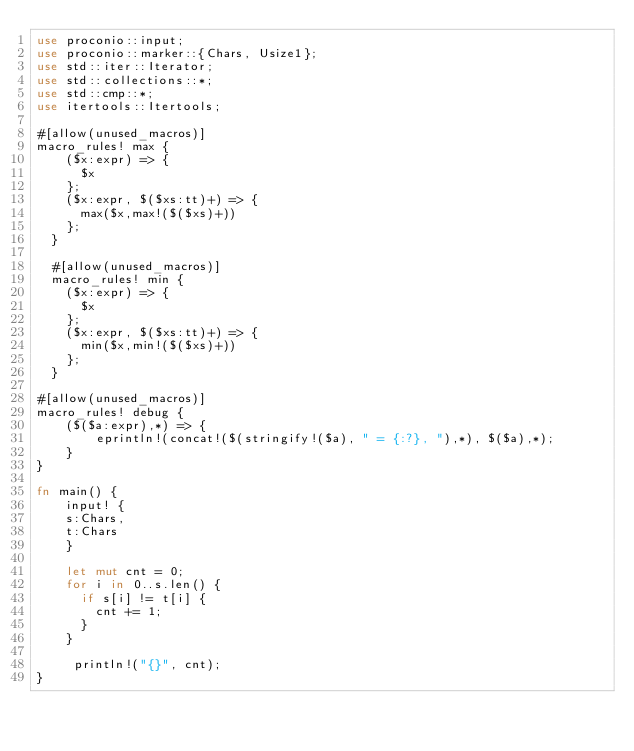Convert code to text. <code><loc_0><loc_0><loc_500><loc_500><_Rust_>use proconio::input;
use proconio::marker::{Chars, Usize1};
use std::iter::Iterator;
use std::collections::*;
use std::cmp::*;
use itertools::Itertools;

#[allow(unused_macros)]
macro_rules! max {
    ($x:expr) => {
      $x
    };
    ($x:expr, $($xs:tt)+) => {
      max($x,max!($($xs)+))
    };
  }
  
  #[allow(unused_macros)]
  macro_rules! min {
    ($x:expr) => {
      $x
    };
    ($x:expr, $($xs:tt)+) => {
      min($x,min!($($xs)+))
    };
  }

#[allow(unused_macros)]
macro_rules! debug {
    ($($a:expr),*) => {
        eprintln!(concat!($(stringify!($a), " = {:?}, "),*), $($a),*);
    }
}

fn main() {
    input! {
    s:Chars,
    t:Chars
    }

    let mut cnt = 0;
    for i in 0..s.len() {
      if s[i] != t[i] {
        cnt += 1;
      }
    }

     println!("{}", cnt);
}
</code> 